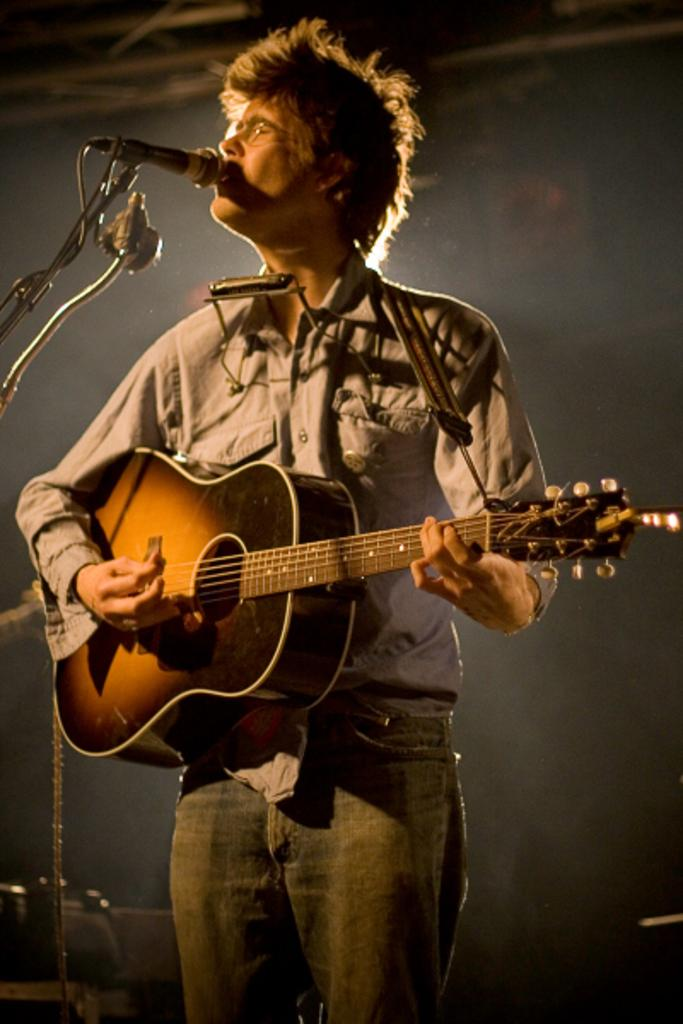What is the main subject of the image? There is a person in the image. What is the person doing in the image? The person is playing a guitar. Can you describe the person's appearance in the image? The person is wearing spectacles and clothes. Can you hear the ship in the image? There is no ship present in the image, so it is not possible to hear a ship. 